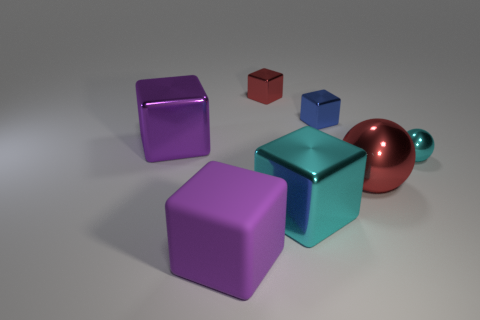Are there fewer small green matte objects than purple matte things? Yes, there are fewer small green matte objects compared to the purple matte objects. In the image, there is one small green matte cube whereas there are two larger purple matte objects, one cube and one other geometric shape, visibly demonstrating that there is a smaller quantity of green matte items. 